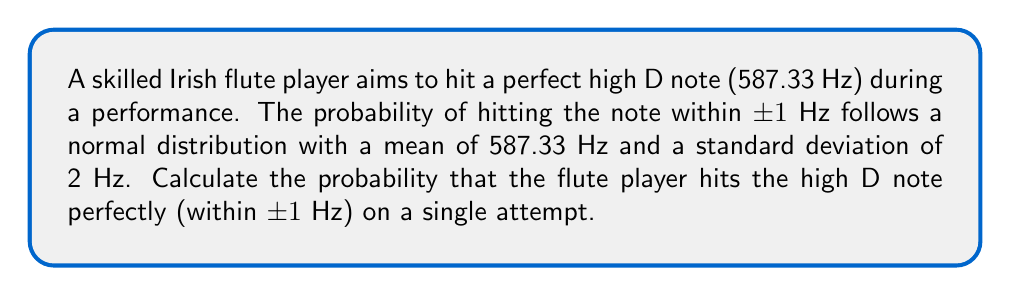Give your solution to this math problem. Let's approach this step-by-step:

1) We're dealing with a normal distribution where:
   $\mu = 587.33$ Hz (mean)
   $\sigma = 2$ Hz (standard deviation)

2) We want to find the probability of the note being within ±1 Hz of the perfect pitch:
   Lower bound: $587.33 - 1 = 586.33$ Hz
   Upper bound: $587.33 + 1 = 588.33$ Hz

3) To calculate this probability, we need to find the z-scores for both bounds:

   For the lower bound: $z_1 = \frac{586.33 - 587.33}{2} = -0.5$
   For the upper bound: $z_2 = \frac{588.33 - 587.33}{2} = 0.5$

4) The probability is the area between these two z-scores on a standard normal distribution.

5) We can calculate this using the cumulative distribution function (CDF) of the standard normal distribution, often denoted as $\Phi(z)$:

   $P(586.33 \leq X \leq 588.33) = \Phi(0.5) - \Phi(-0.5)$

6) Using a standard normal table or calculator:
   $\Phi(0.5) \approx 0.6915$
   $\Phi(-0.5) \approx 0.3085$

7) Therefore, the probability is:
   $0.6915 - 0.3085 = 0.3830$ or about 38.30%
Answer: $0.3830$ or $38.30\%$ 